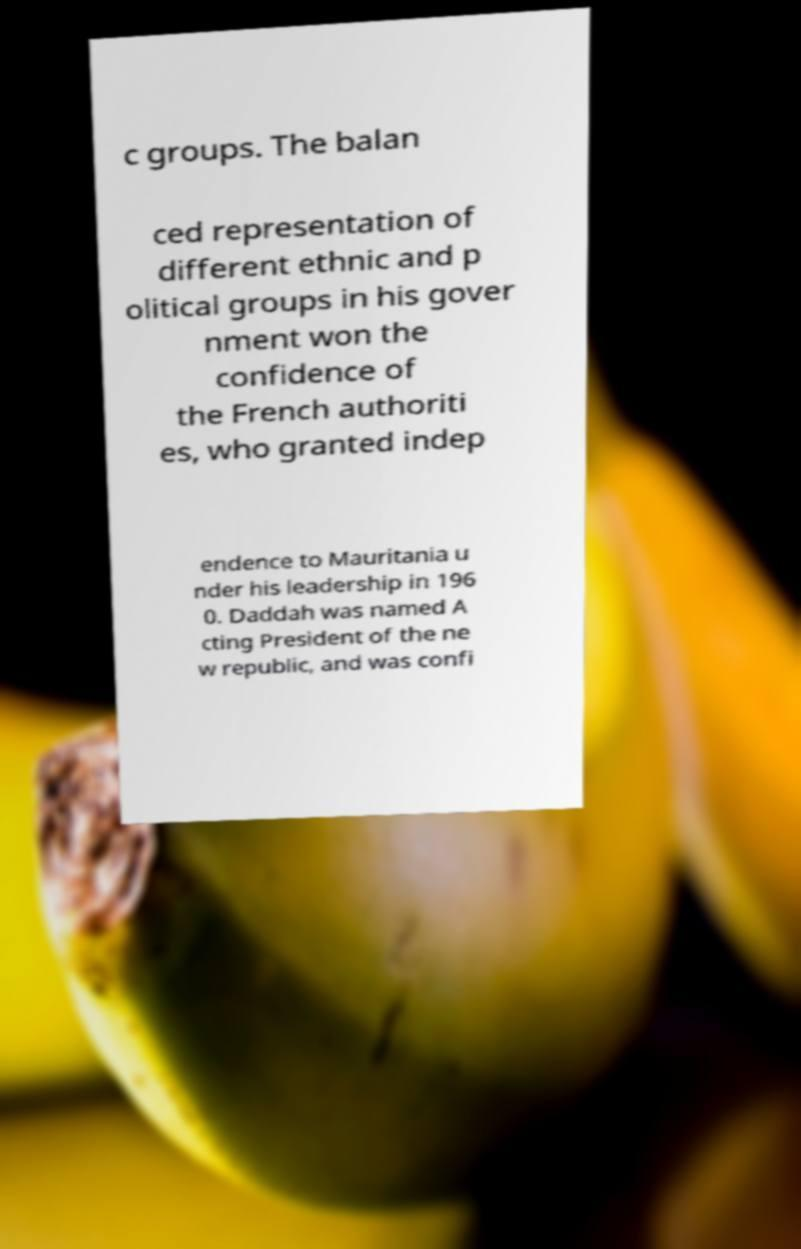There's text embedded in this image that I need extracted. Can you transcribe it verbatim? c groups. The balan ced representation of different ethnic and p olitical groups in his gover nment won the confidence of the French authoriti es, who granted indep endence to Mauritania u nder his leadership in 196 0. Daddah was named A cting President of the ne w republic, and was confi 